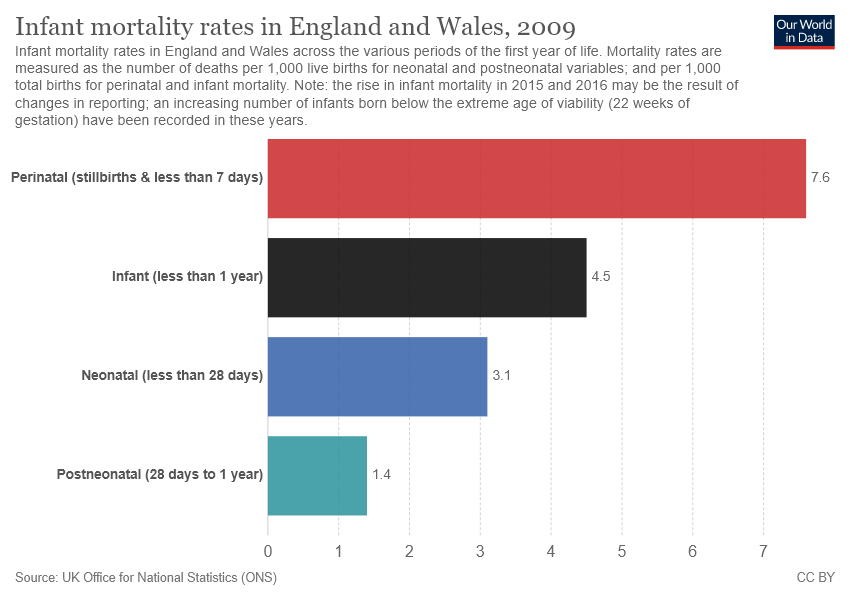Give some essential details in this illustration. The sum of the smallest two bars is equal to the value of the second largest bar. The value of the smallest bar is 1.4. 